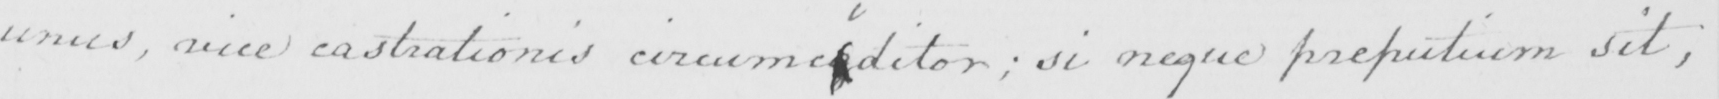What does this handwritten line say? unus , vice castrationis circumciditor ; si neque preputium sit , 